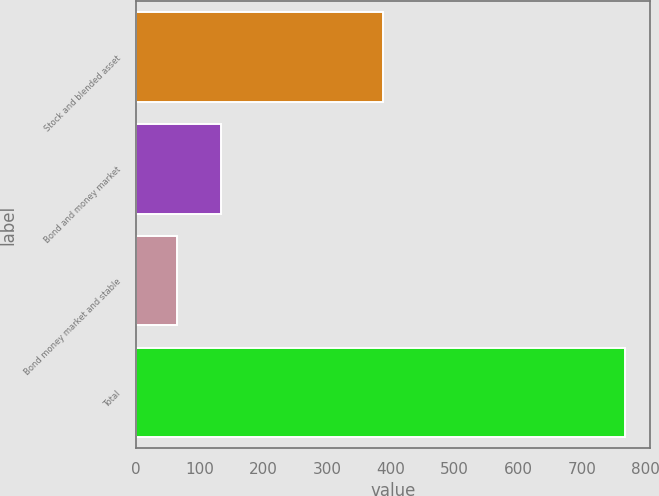Convert chart. <chart><loc_0><loc_0><loc_500><loc_500><bar_chart><fcel>Stock and blended asset<fcel>Bond and money market<fcel>Bond money market and stable<fcel>Total<nl><fcel>387.8<fcel>134.39<fcel>64<fcel>767.9<nl></chart> 